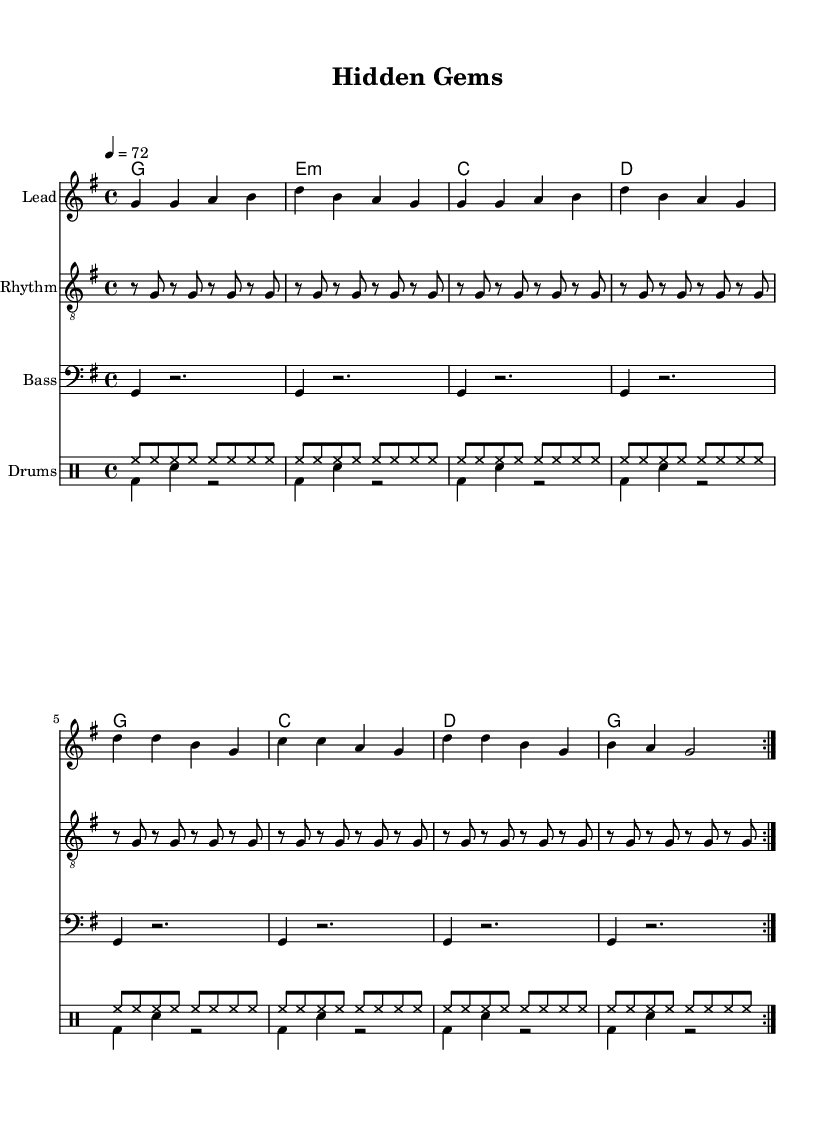What is the key signature of this music? The key signature indicated by the global instructions at the beginning of the code specifies G major, which has one sharp (F sharp) in its scale.
Answer: G major What is the time signature of this music? The time signature specified in the global instructions is 4/4, meaning there are four beats per measure.
Answer: 4/4 What is the tempo of this music? The tempo marking in the global section indicates that the music should be played at 72 beats per minute, which suggests a moderate pace.
Answer: 72 How many measures are in the verse section? By counting the measures in the melody part labeled for the verse, we find that there are 8 measures repeated two times, totaling 16 measures.
Answer: 16 Which chords are used in the chorus? Looking at the chord mode section, the chords listed for the chorus part are G, C, D, and back to G, in that order.
Answer: G, C, D What characteristic drumming style is represented here? The drumming elements specified include high-hat and bass drum patterns typical of reggae music, emphasizing offbeats and syncopation.
Answer: Reggae drumming What theme is portrayed in the lyrics of this song? The lyrics describe the journey of searching for hidden property gems, reflecting themes of exploration and potential in real estate.
Answer: Searching for hidden property gems 